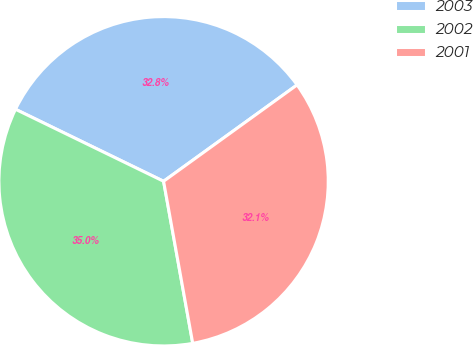Convert chart. <chart><loc_0><loc_0><loc_500><loc_500><pie_chart><fcel>2003<fcel>2002<fcel>2001<nl><fcel>32.85%<fcel>35.04%<fcel>32.12%<nl></chart> 